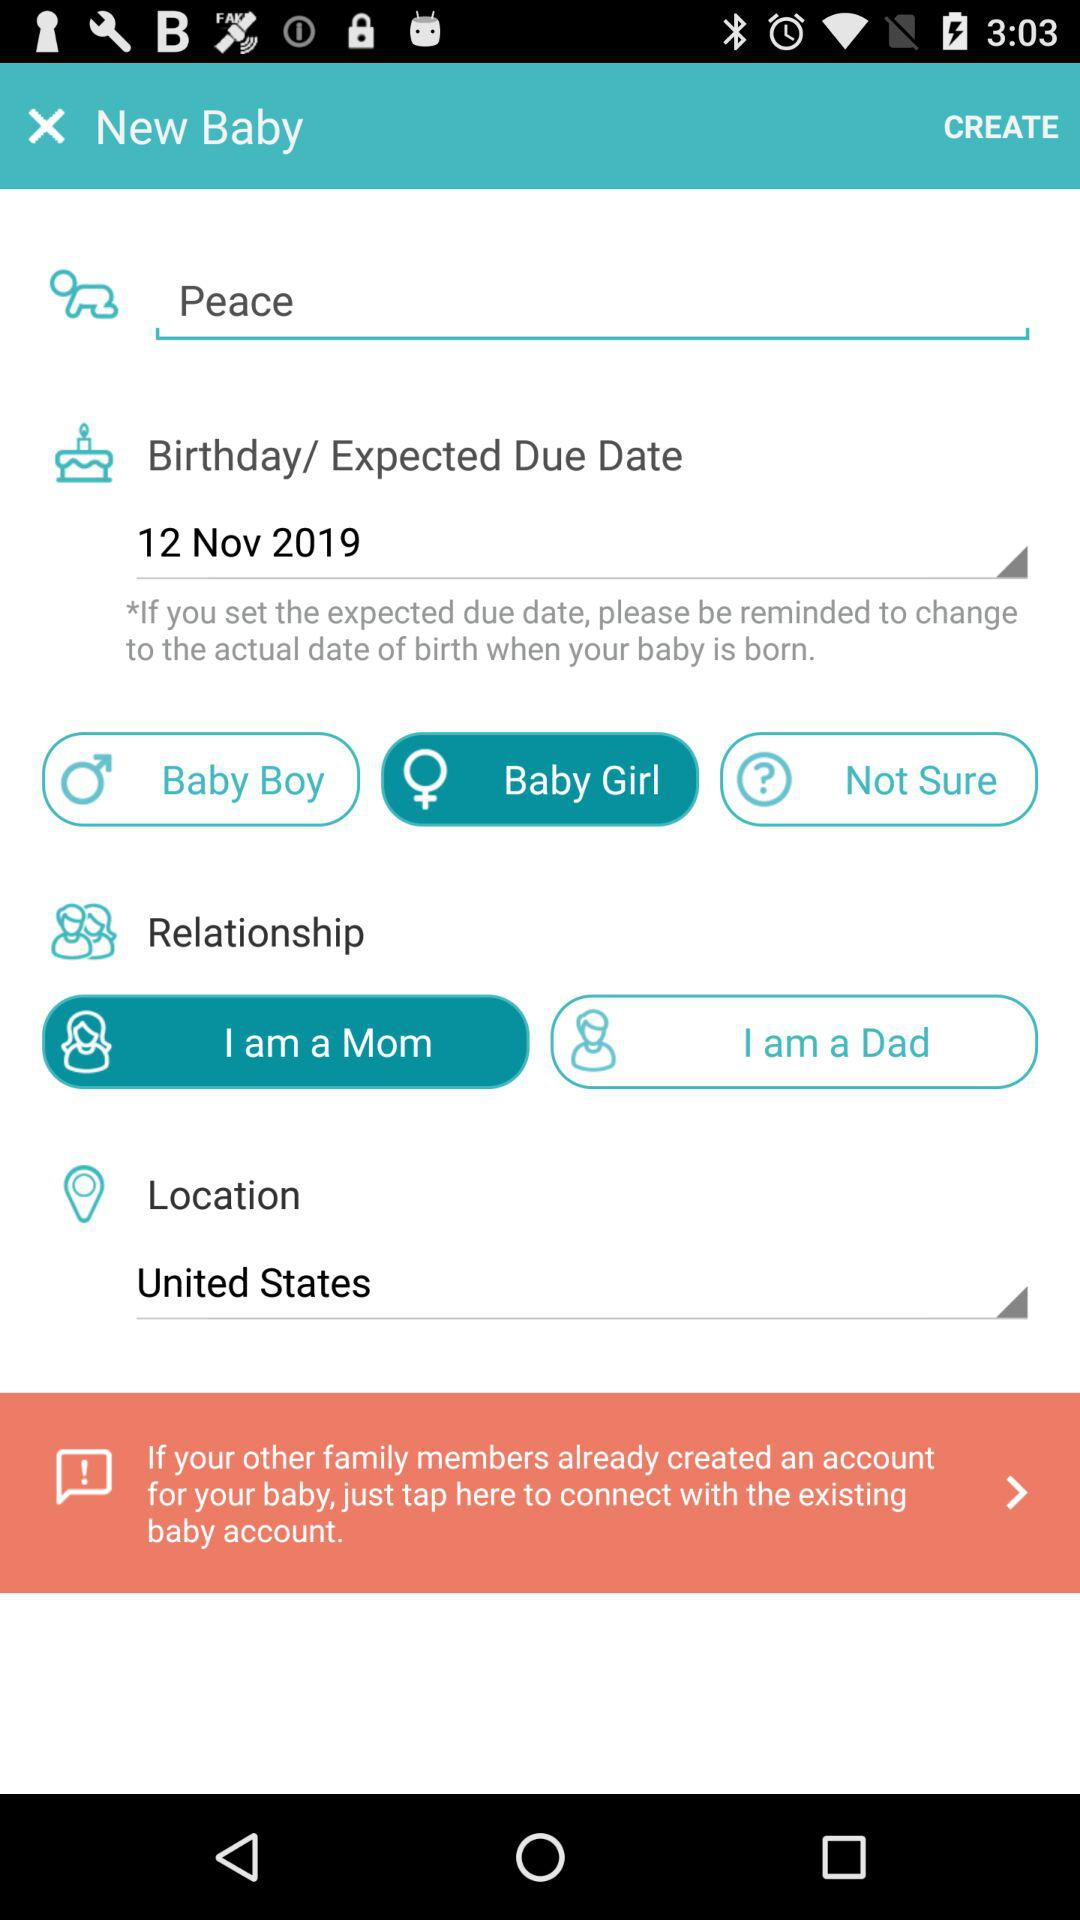What is the name of the baby? The name of the baby is Peace. 